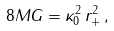Convert formula to latex. <formula><loc_0><loc_0><loc_500><loc_500>8 M G = \kappa _ { 0 } ^ { 2 } \, r _ { + } ^ { 2 } \, ,</formula> 